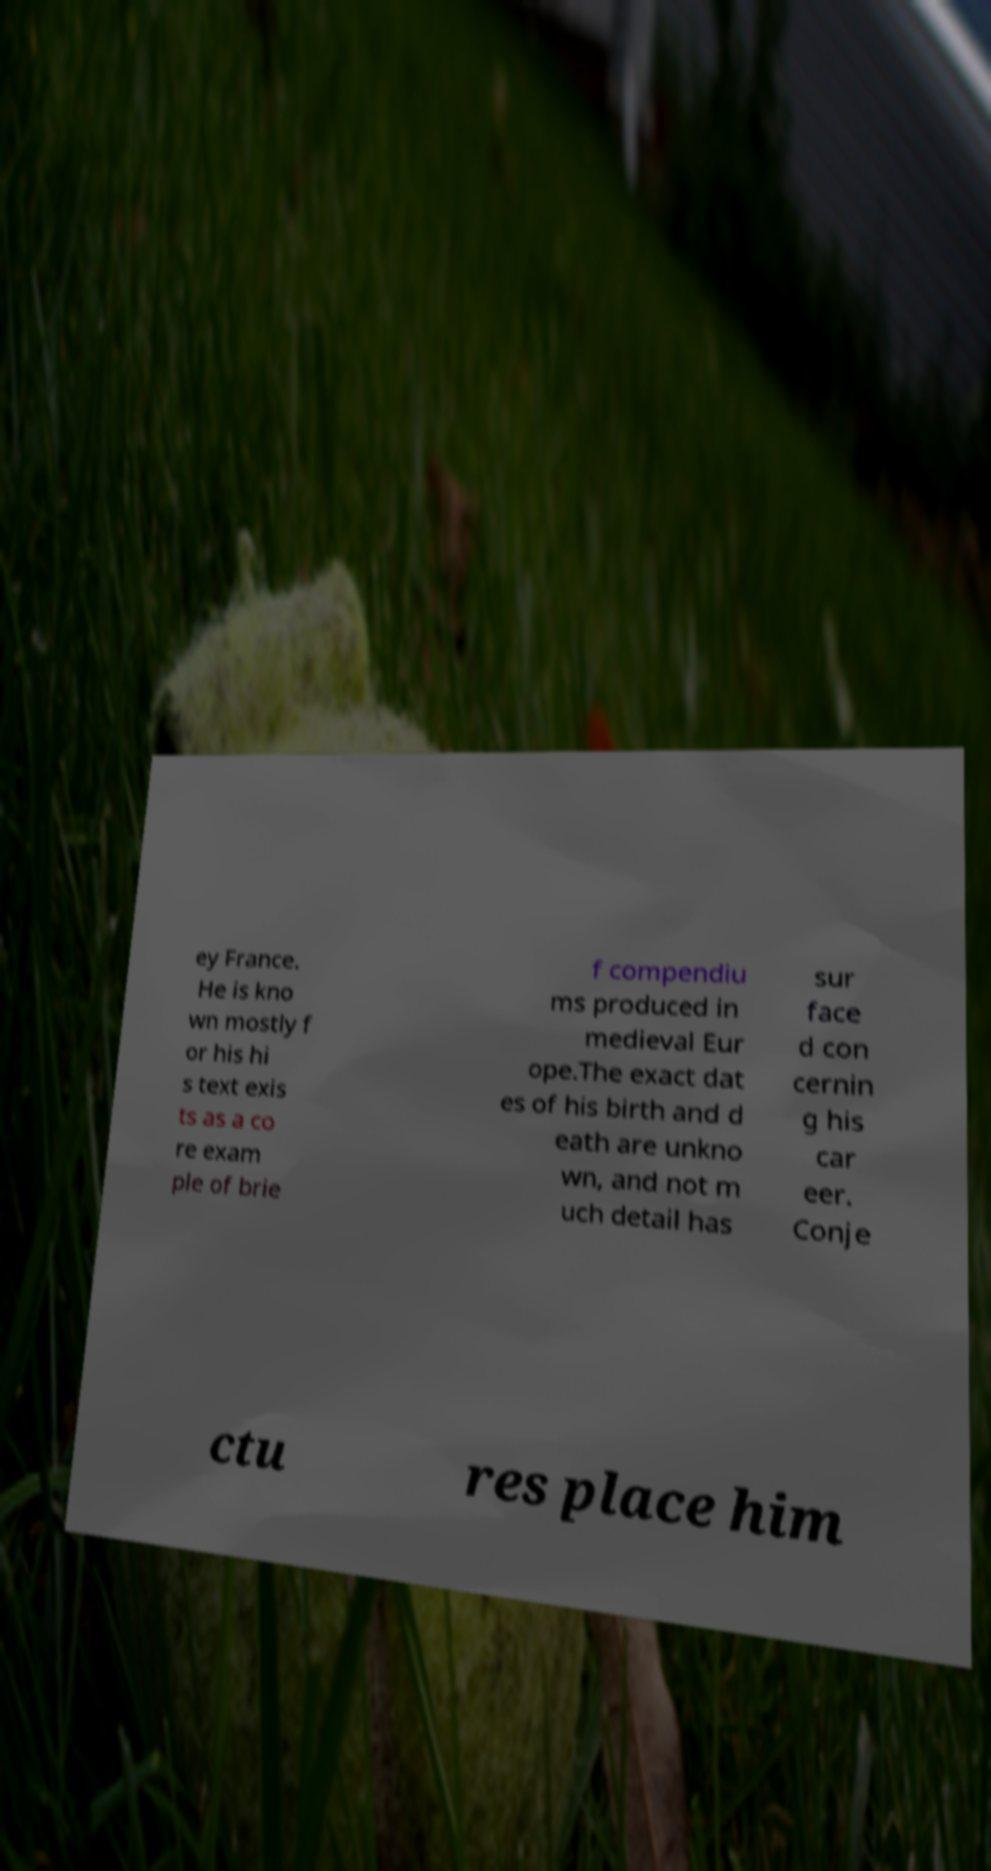Could you extract and type out the text from this image? ey France. He is kno wn mostly f or his hi s text exis ts as a co re exam ple of brie f compendiu ms produced in medieval Eur ope.The exact dat es of his birth and d eath are unkno wn, and not m uch detail has sur face d con cernin g his car eer. Conje ctu res place him 